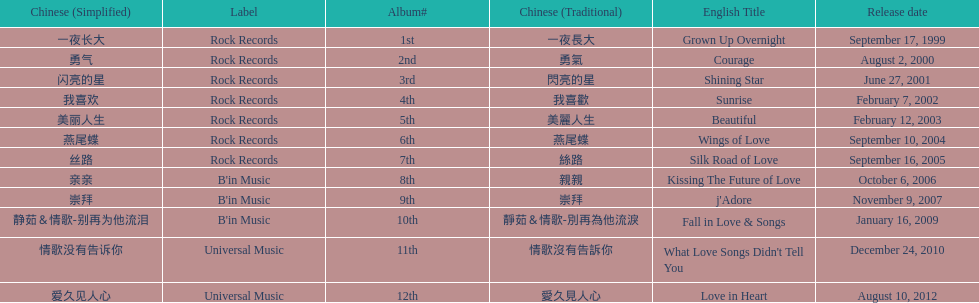What is the number of songs on rock records? 7. 